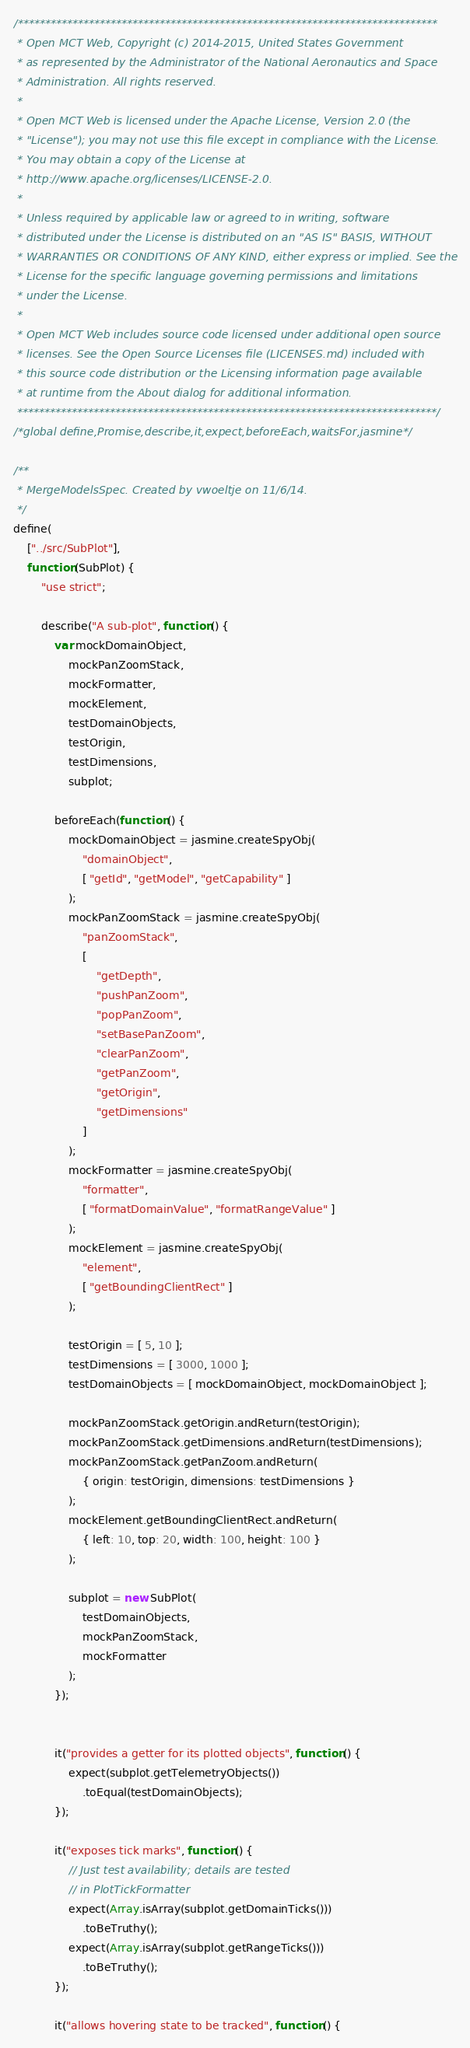<code> <loc_0><loc_0><loc_500><loc_500><_JavaScript_>/*****************************************************************************
 * Open MCT Web, Copyright (c) 2014-2015, United States Government
 * as represented by the Administrator of the National Aeronautics and Space
 * Administration. All rights reserved.
 *
 * Open MCT Web is licensed under the Apache License, Version 2.0 (the
 * "License"); you may not use this file except in compliance with the License.
 * You may obtain a copy of the License at
 * http://www.apache.org/licenses/LICENSE-2.0.
 *
 * Unless required by applicable law or agreed to in writing, software
 * distributed under the License is distributed on an "AS IS" BASIS, WITHOUT
 * WARRANTIES OR CONDITIONS OF ANY KIND, either express or implied. See the
 * License for the specific language governing permissions and limitations
 * under the License.
 *
 * Open MCT Web includes source code licensed under additional open source
 * licenses. See the Open Source Licenses file (LICENSES.md) included with
 * this source code distribution or the Licensing information page available
 * at runtime from the About dialog for additional information.
 *****************************************************************************/
/*global define,Promise,describe,it,expect,beforeEach,waitsFor,jasmine*/

/**
 * MergeModelsSpec. Created by vwoeltje on 11/6/14.
 */
define(
    ["../src/SubPlot"],
    function (SubPlot) {
        "use strict";

        describe("A sub-plot", function () {
            var mockDomainObject,
                mockPanZoomStack,
                mockFormatter,
                mockElement,
                testDomainObjects,
                testOrigin,
                testDimensions,
                subplot;

            beforeEach(function () {
                mockDomainObject = jasmine.createSpyObj(
                    "domainObject",
                    [ "getId", "getModel", "getCapability" ]
                );
                mockPanZoomStack = jasmine.createSpyObj(
                    "panZoomStack",
                    [
                        "getDepth",
                        "pushPanZoom",
                        "popPanZoom",
                        "setBasePanZoom",
                        "clearPanZoom",
                        "getPanZoom",
                        "getOrigin",
                        "getDimensions"
                    ]
                );
                mockFormatter = jasmine.createSpyObj(
                    "formatter",
                    [ "formatDomainValue", "formatRangeValue" ]
                );
                mockElement = jasmine.createSpyObj(
                    "element",
                    [ "getBoundingClientRect" ]
                );

                testOrigin = [ 5, 10 ];
                testDimensions = [ 3000, 1000 ];
                testDomainObjects = [ mockDomainObject, mockDomainObject ];

                mockPanZoomStack.getOrigin.andReturn(testOrigin);
                mockPanZoomStack.getDimensions.andReturn(testDimensions);
                mockPanZoomStack.getPanZoom.andReturn(
                    { origin: testOrigin, dimensions: testDimensions }
                );
                mockElement.getBoundingClientRect.andReturn(
                    { left: 10, top: 20, width: 100, height: 100 }
                );

                subplot = new SubPlot(
                    testDomainObjects,
                    mockPanZoomStack,
                    mockFormatter
                );
            });


            it("provides a getter for its plotted objects", function () {
                expect(subplot.getTelemetryObjects())
                    .toEqual(testDomainObjects);
            });

            it("exposes tick marks", function () {
                // Just test availability; details are tested
                // in PlotTickFormatter
                expect(Array.isArray(subplot.getDomainTicks()))
                    .toBeTruthy();
                expect(Array.isArray(subplot.getRangeTicks()))
                    .toBeTruthy();
            });

            it("allows hovering state to be tracked", function () {</code> 